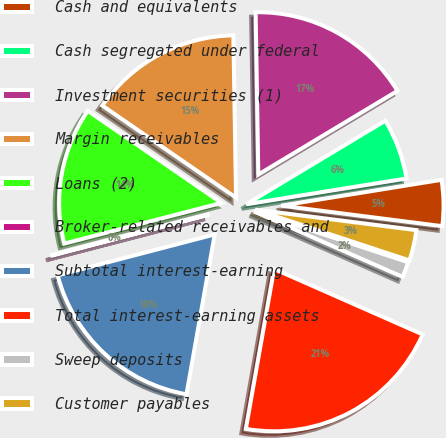Convert chart to OTSL. <chart><loc_0><loc_0><loc_500><loc_500><pie_chart><fcel>Cash and equivalents<fcel>Cash segregated under federal<fcel>Investment securities (1)<fcel>Margin receivables<fcel>Loans (2)<fcel>Broker-related receivables and<fcel>Subtotal interest-earning<fcel>Total interest-earning assets<fcel>Sweep deposits<fcel>Customer payables<nl><fcel>4.56%<fcel>6.07%<fcel>16.65%<fcel>15.14%<fcel>13.63%<fcel>0.03%<fcel>18.16%<fcel>21.18%<fcel>1.54%<fcel>3.05%<nl></chart> 